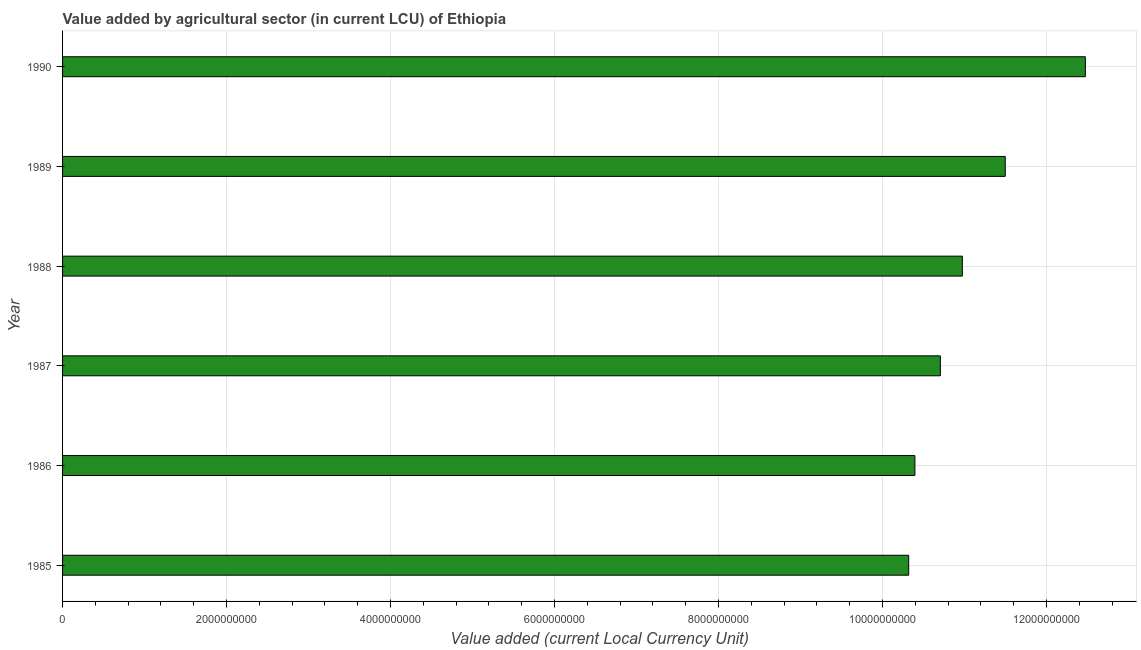Does the graph contain any zero values?
Give a very brief answer. No. Does the graph contain grids?
Keep it short and to the point. Yes. What is the title of the graph?
Your response must be concise. Value added by agricultural sector (in current LCU) of Ethiopia. What is the label or title of the X-axis?
Your response must be concise. Value added (current Local Currency Unit). What is the value added by agriculture sector in 1987?
Your answer should be compact. 1.07e+1. Across all years, what is the maximum value added by agriculture sector?
Ensure brevity in your answer.  1.25e+1. Across all years, what is the minimum value added by agriculture sector?
Offer a terse response. 1.03e+1. In which year was the value added by agriculture sector maximum?
Offer a terse response. 1990. What is the sum of the value added by agriculture sector?
Offer a terse response. 6.64e+1. What is the difference between the value added by agriculture sector in 1989 and 1990?
Keep it short and to the point. -9.77e+08. What is the average value added by agriculture sector per year?
Ensure brevity in your answer.  1.11e+1. What is the median value added by agriculture sector?
Provide a succinct answer. 1.08e+1. In how many years, is the value added by agriculture sector greater than 2000000000 LCU?
Your answer should be very brief. 6. Do a majority of the years between 1985 and 1988 (inclusive) have value added by agriculture sector greater than 9600000000 LCU?
Your answer should be very brief. Yes. What is the ratio of the value added by agriculture sector in 1986 to that in 1988?
Give a very brief answer. 0.95. What is the difference between the highest and the second highest value added by agriculture sector?
Your response must be concise. 9.77e+08. Is the sum of the value added by agriculture sector in 1986 and 1990 greater than the maximum value added by agriculture sector across all years?
Offer a terse response. Yes. What is the difference between the highest and the lowest value added by agriculture sector?
Your answer should be compact. 2.15e+09. In how many years, is the value added by agriculture sector greater than the average value added by agriculture sector taken over all years?
Offer a terse response. 2. Are all the bars in the graph horizontal?
Make the answer very short. Yes. Are the values on the major ticks of X-axis written in scientific E-notation?
Keep it short and to the point. No. What is the Value added (current Local Currency Unit) in 1985?
Make the answer very short. 1.03e+1. What is the Value added (current Local Currency Unit) in 1986?
Offer a very short reply. 1.04e+1. What is the Value added (current Local Currency Unit) of 1987?
Your response must be concise. 1.07e+1. What is the Value added (current Local Currency Unit) in 1988?
Your response must be concise. 1.10e+1. What is the Value added (current Local Currency Unit) in 1989?
Offer a terse response. 1.15e+1. What is the Value added (current Local Currency Unit) of 1990?
Your response must be concise. 1.25e+1. What is the difference between the Value added (current Local Currency Unit) in 1985 and 1986?
Offer a very short reply. -7.57e+07. What is the difference between the Value added (current Local Currency Unit) in 1985 and 1987?
Offer a very short reply. -3.86e+08. What is the difference between the Value added (current Local Currency Unit) in 1985 and 1988?
Provide a short and direct response. -6.54e+08. What is the difference between the Value added (current Local Currency Unit) in 1985 and 1989?
Make the answer very short. -1.18e+09. What is the difference between the Value added (current Local Currency Unit) in 1985 and 1990?
Make the answer very short. -2.15e+09. What is the difference between the Value added (current Local Currency Unit) in 1986 and 1987?
Provide a short and direct response. -3.11e+08. What is the difference between the Value added (current Local Currency Unit) in 1986 and 1988?
Keep it short and to the point. -5.79e+08. What is the difference between the Value added (current Local Currency Unit) in 1986 and 1989?
Give a very brief answer. -1.10e+09. What is the difference between the Value added (current Local Currency Unit) in 1986 and 1990?
Provide a succinct answer. -2.08e+09. What is the difference between the Value added (current Local Currency Unit) in 1987 and 1988?
Keep it short and to the point. -2.68e+08. What is the difference between the Value added (current Local Currency Unit) in 1987 and 1989?
Your answer should be compact. -7.91e+08. What is the difference between the Value added (current Local Currency Unit) in 1987 and 1990?
Ensure brevity in your answer.  -1.77e+09. What is the difference between the Value added (current Local Currency Unit) in 1988 and 1989?
Provide a short and direct response. -5.23e+08. What is the difference between the Value added (current Local Currency Unit) in 1988 and 1990?
Provide a short and direct response. -1.50e+09. What is the difference between the Value added (current Local Currency Unit) in 1989 and 1990?
Give a very brief answer. -9.77e+08. What is the ratio of the Value added (current Local Currency Unit) in 1985 to that in 1986?
Provide a succinct answer. 0.99. What is the ratio of the Value added (current Local Currency Unit) in 1985 to that in 1988?
Give a very brief answer. 0.94. What is the ratio of the Value added (current Local Currency Unit) in 1985 to that in 1989?
Give a very brief answer. 0.9. What is the ratio of the Value added (current Local Currency Unit) in 1985 to that in 1990?
Your answer should be very brief. 0.83. What is the ratio of the Value added (current Local Currency Unit) in 1986 to that in 1988?
Provide a succinct answer. 0.95. What is the ratio of the Value added (current Local Currency Unit) in 1986 to that in 1989?
Your response must be concise. 0.9. What is the ratio of the Value added (current Local Currency Unit) in 1986 to that in 1990?
Keep it short and to the point. 0.83. What is the ratio of the Value added (current Local Currency Unit) in 1987 to that in 1988?
Give a very brief answer. 0.98. What is the ratio of the Value added (current Local Currency Unit) in 1987 to that in 1989?
Your answer should be very brief. 0.93. What is the ratio of the Value added (current Local Currency Unit) in 1987 to that in 1990?
Ensure brevity in your answer.  0.86. What is the ratio of the Value added (current Local Currency Unit) in 1988 to that in 1989?
Your answer should be very brief. 0.95. What is the ratio of the Value added (current Local Currency Unit) in 1989 to that in 1990?
Ensure brevity in your answer.  0.92. 